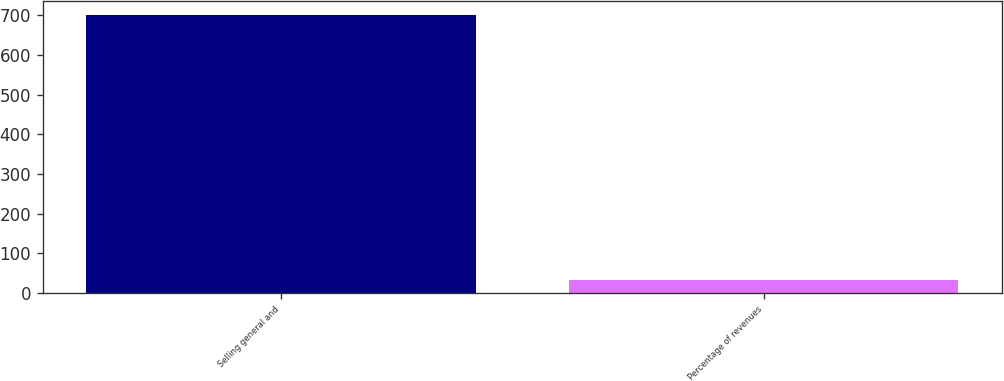<chart> <loc_0><loc_0><loc_500><loc_500><bar_chart><fcel>Selling general and<fcel>Percentage of revenues<nl><fcel>700<fcel>32.6<nl></chart> 